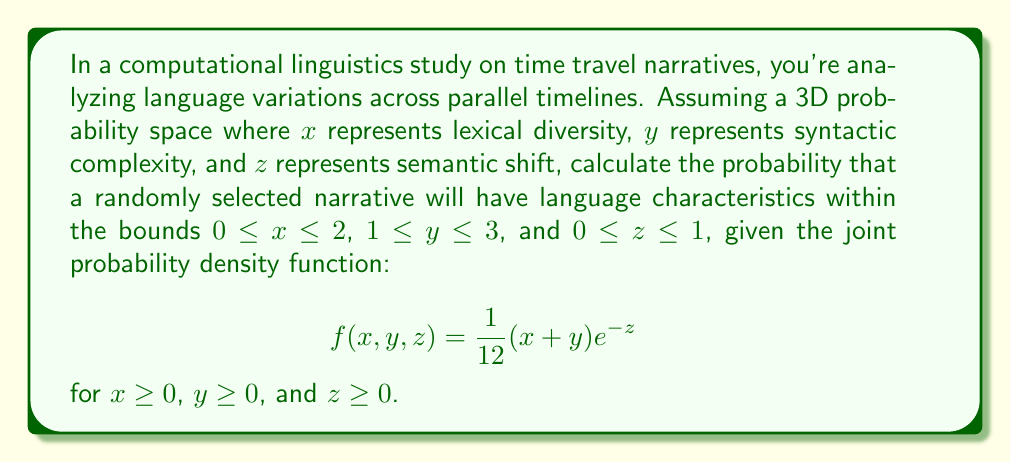Show me your answer to this math problem. To solve this problem, we need to use a triple integral to calculate the probability over the given bounds. The steps are as follows:

1) Set up the triple integral using the given bounds and probability density function:

   $$P = \int_{0}^{1} \int_{1}^{3} \int_{0}^{2} \frac{1}{12}(x+y)e^{-z} \, dx \, dy \, dz$$

2) First, integrate with respect to x:

   $$\int_{0}^{1} \int_{1}^{3} \left[ \frac{1}{12}(\frac{1}{2}x^2 + yx)e^{-z} \right]_{0}^{2} \, dy \, dz$$
   
   $$= \int_{0}^{1} \int_{1}^{3} \frac{1}{12}(2 + 2y)e^{-z} \, dy \, dz$$

3) Now integrate with respect to y:

   $$\int_{0}^{1} \left[ \frac{1}{12}(2y + y^2)e^{-z} \right]_{1}^{3} \, dz$$
   
   $$= \int_{0}^{1} \frac{1}{12}(6 + 9 - 2 - 1)e^{-z} \, dz$$
   
   $$= \int_{0}^{1} \frac{1}{12}(12)e^{-z} \, dz = \int_{0}^{1} e^{-z} \, dz$$

4) Finally, integrate with respect to z:

   $$\left[ -e^{-z} \right]_{0}^{1} = -e^{-1} - (-e^{0}) = -\frac{1}{e} + 1$$

5) Simplify the result:

   $$P = 1 - \frac{1}{e} \approx 0.6321$$
Answer: The probability that a randomly selected narrative will have language characteristics within the given bounds is $1 - \frac{1}{e}$, or approximately 0.6321 (63.21%). 